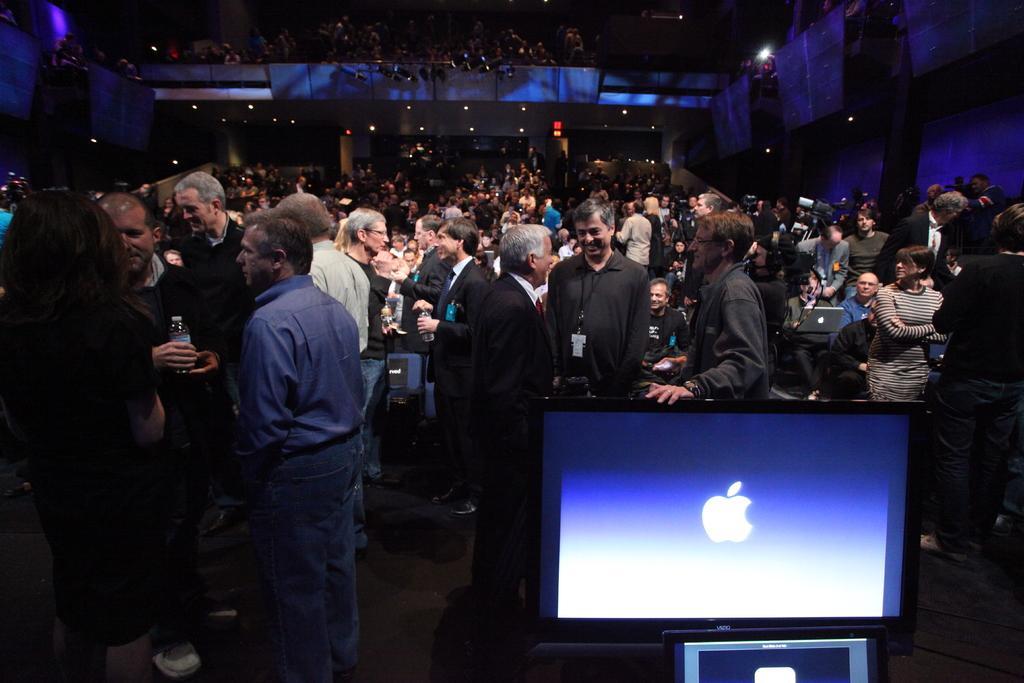Describe this image in one or two sentences. In this image there is a monitor, in the background there are a few people standing and few are sitting on chairs. 